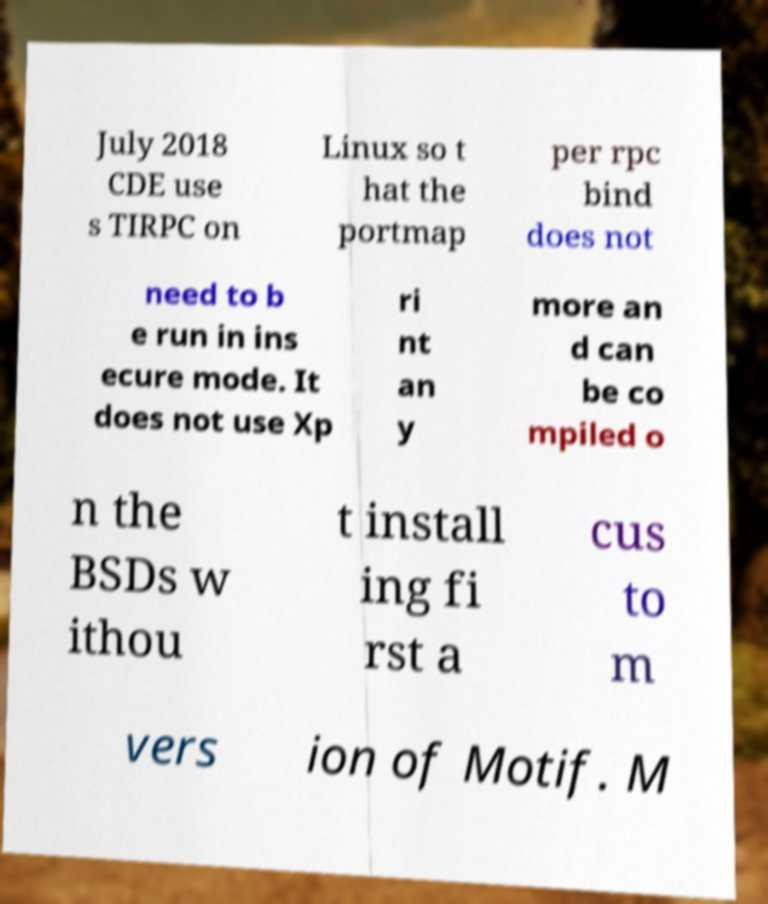I need the written content from this picture converted into text. Can you do that? July 2018 CDE use s TIRPC on Linux so t hat the portmap per rpc bind does not need to b e run in ins ecure mode. It does not use Xp ri nt an y more an d can be co mpiled o n the BSDs w ithou t install ing fi rst a cus to m vers ion of Motif. M 